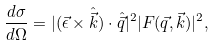<formula> <loc_0><loc_0><loc_500><loc_500>\frac { d \sigma } { d \Omega } = | ( \vec { \epsilon } \times \hat { \vec { k } } ) \cdot \hat { \vec { q } } | ^ { 2 } | F ( \vec { q } , \vec { k } ) | ^ { 2 } ,</formula> 